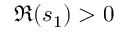<formula> <loc_0><loc_0><loc_500><loc_500>\Re { ( s _ { 1 } ) } > 0</formula> 